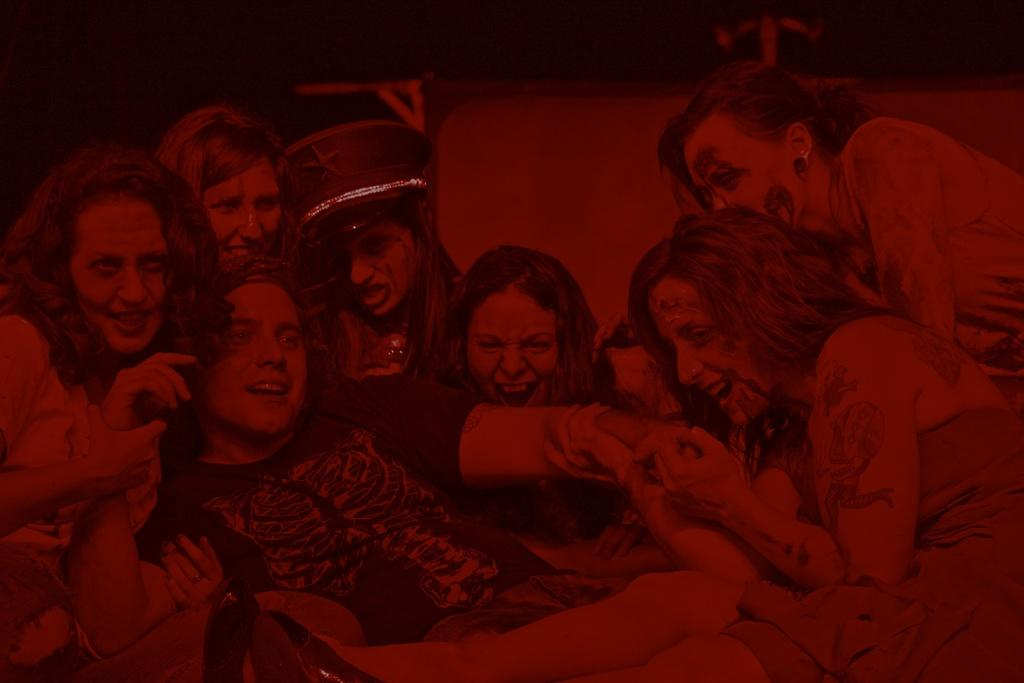What is the dominant color in the image? The image is in red color. What can be seen in terms of human presence in the image? There are people sitting in the image. How many eggs are being cooked in a pan in the image? There is no pan or eggs present in the image; it only features people sitting in a red environment. 